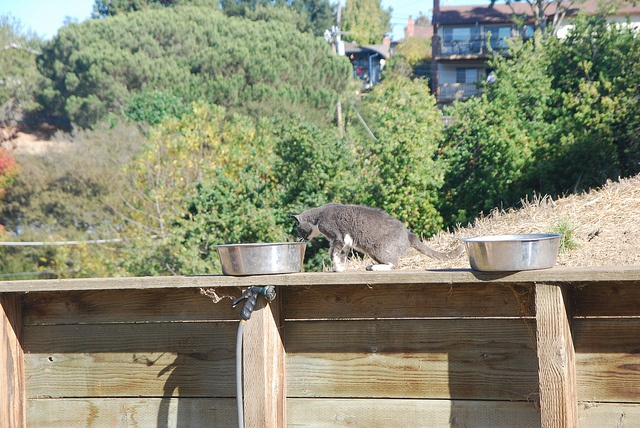Describe the objects in this image and their specific colors. I can see cat in lightblue, darkgray, gray, and lightgray tones, bowl in lightblue, darkgray, lightgray, and tan tones, and bowl in lightblue, darkgray, lightgray, and gray tones in this image. 